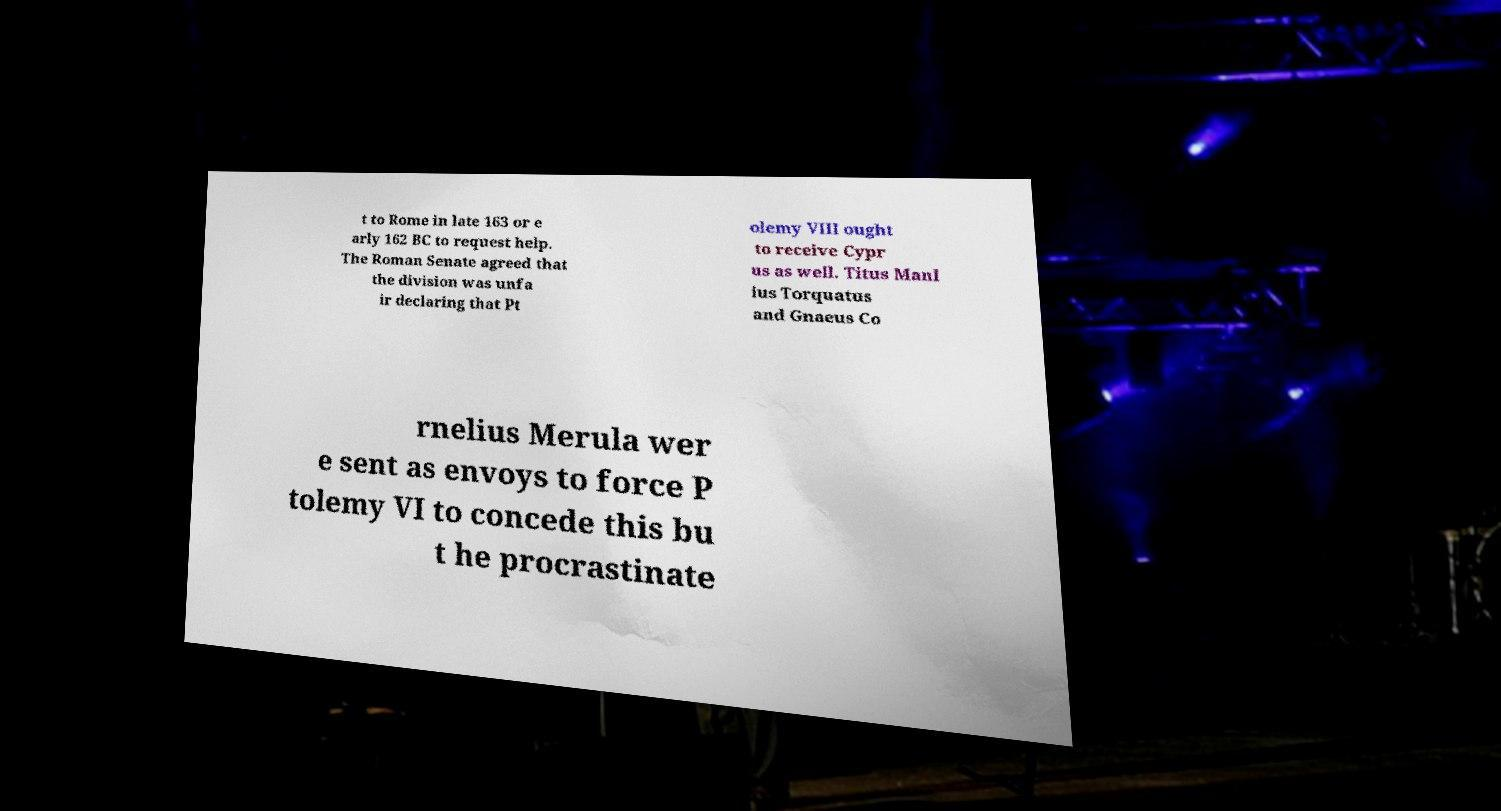Please identify and transcribe the text found in this image. t to Rome in late 163 or e arly 162 BC to request help. The Roman Senate agreed that the division was unfa ir declaring that Pt olemy VIII ought to receive Cypr us as well. Titus Manl ius Torquatus and Gnaeus Co rnelius Merula wer e sent as envoys to force P tolemy VI to concede this bu t he procrastinate 